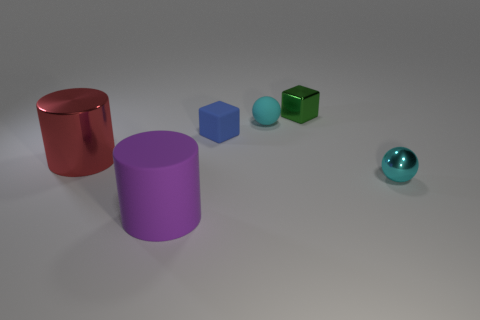Add 1 shiny cylinders. How many objects exist? 7 Subtract all cubes. How many objects are left? 4 Subtract 0 green spheres. How many objects are left? 6 Subtract all tiny green blocks. Subtract all large cylinders. How many objects are left? 3 Add 4 small blue blocks. How many small blue blocks are left? 5 Add 2 small brown metallic spheres. How many small brown metallic spheres exist? 2 